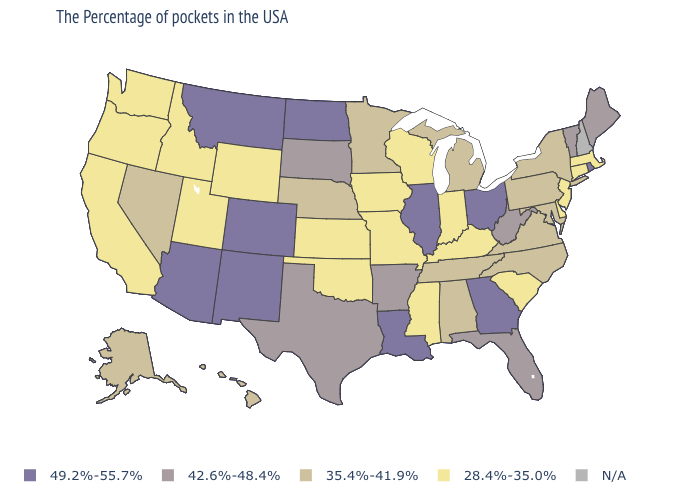Name the states that have a value in the range 42.6%-48.4%?
Short answer required. Maine, Vermont, West Virginia, Florida, Arkansas, Texas, South Dakota. What is the value of Idaho?
Concise answer only. 28.4%-35.0%. What is the value of Maine?
Give a very brief answer. 42.6%-48.4%. Among the states that border Colorado , which have the highest value?
Quick response, please. New Mexico, Arizona. What is the value of Massachusetts?
Quick response, please. 28.4%-35.0%. What is the value of Mississippi?
Short answer required. 28.4%-35.0%. What is the value of Alaska?
Short answer required. 35.4%-41.9%. Among the states that border Kansas , which have the lowest value?
Short answer required. Missouri, Oklahoma. Which states have the highest value in the USA?
Be succinct. Rhode Island, Ohio, Georgia, Illinois, Louisiana, North Dakota, Colorado, New Mexico, Montana, Arizona. Is the legend a continuous bar?
Concise answer only. No. Does Arkansas have the highest value in the USA?
Be succinct. No. Name the states that have a value in the range 49.2%-55.7%?
Be succinct. Rhode Island, Ohio, Georgia, Illinois, Louisiana, North Dakota, Colorado, New Mexico, Montana, Arizona. Name the states that have a value in the range N/A?
Give a very brief answer. New Hampshire. Which states have the highest value in the USA?
Keep it brief. Rhode Island, Ohio, Georgia, Illinois, Louisiana, North Dakota, Colorado, New Mexico, Montana, Arizona. 